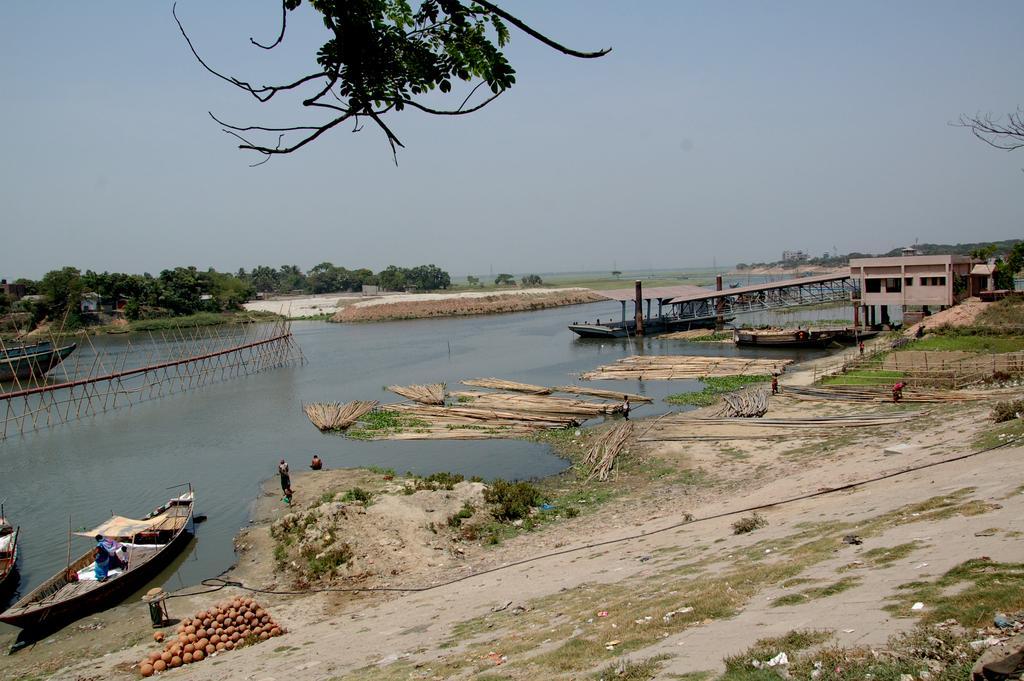Describe this image in one or two sentences. In this image we can see land, pond, boats, pots, building, trees and humans. The sky is in blue color. Top of the image branch of a tree is present. 